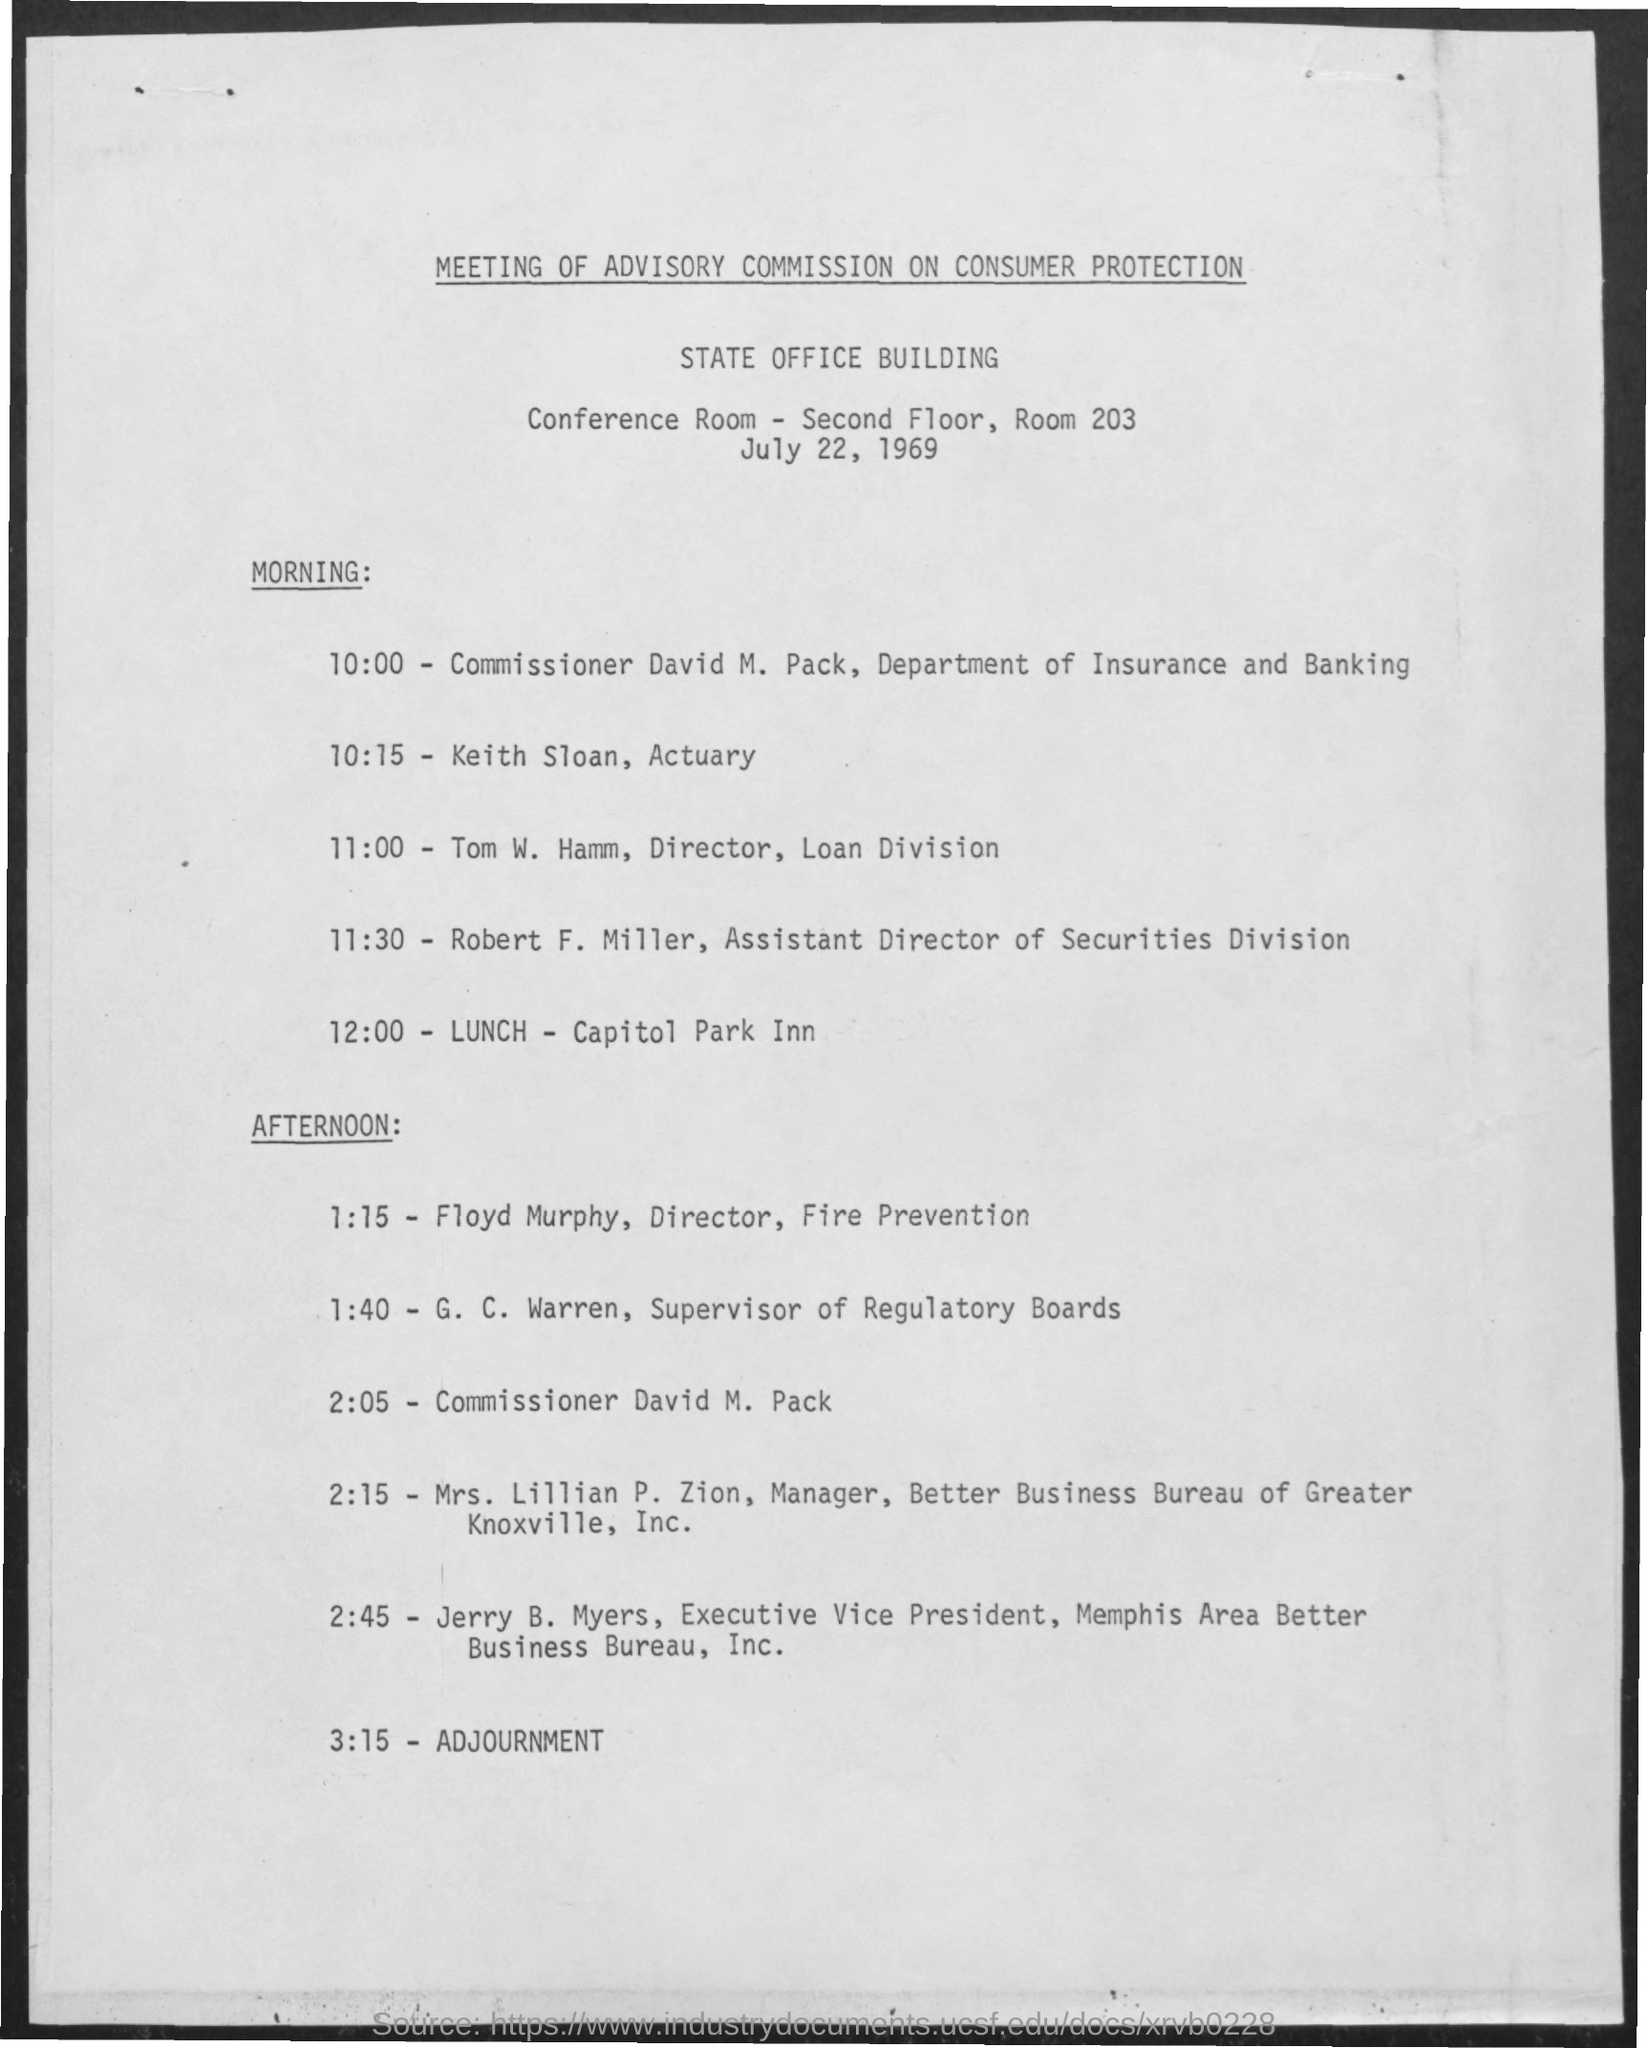Can you tell me more about the event mentioned in this document? Certainly! The image shows a schedule for the Meeting of the Advisory Commission on Consumer Protection, which was set to occur on July 22, 1969. It details the time, participants, and proceedings of the morning and afternoon sessions, including talks by various directors and managers related to consumer protection and regulations. 